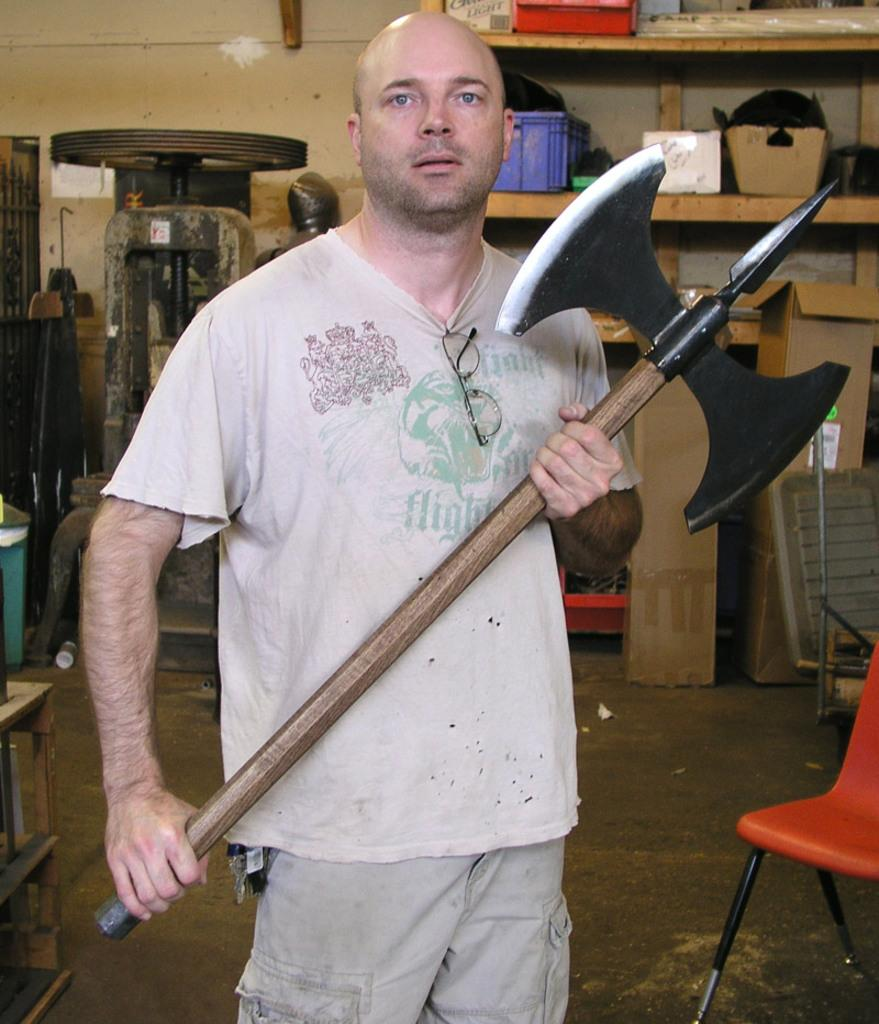Who is the main subject in the image? There is a man in the image. Where is the man positioned in the image? The man is standing in the center of the image. What is the man holding in his hand? The man is holding a weapon in his hand. What can be seen in the background of the image? There is a chair in the background of the image. What type of songs can be heard playing in the background of the image? There is no indication of any songs or music in the image, so it cannot be determined from the image. 